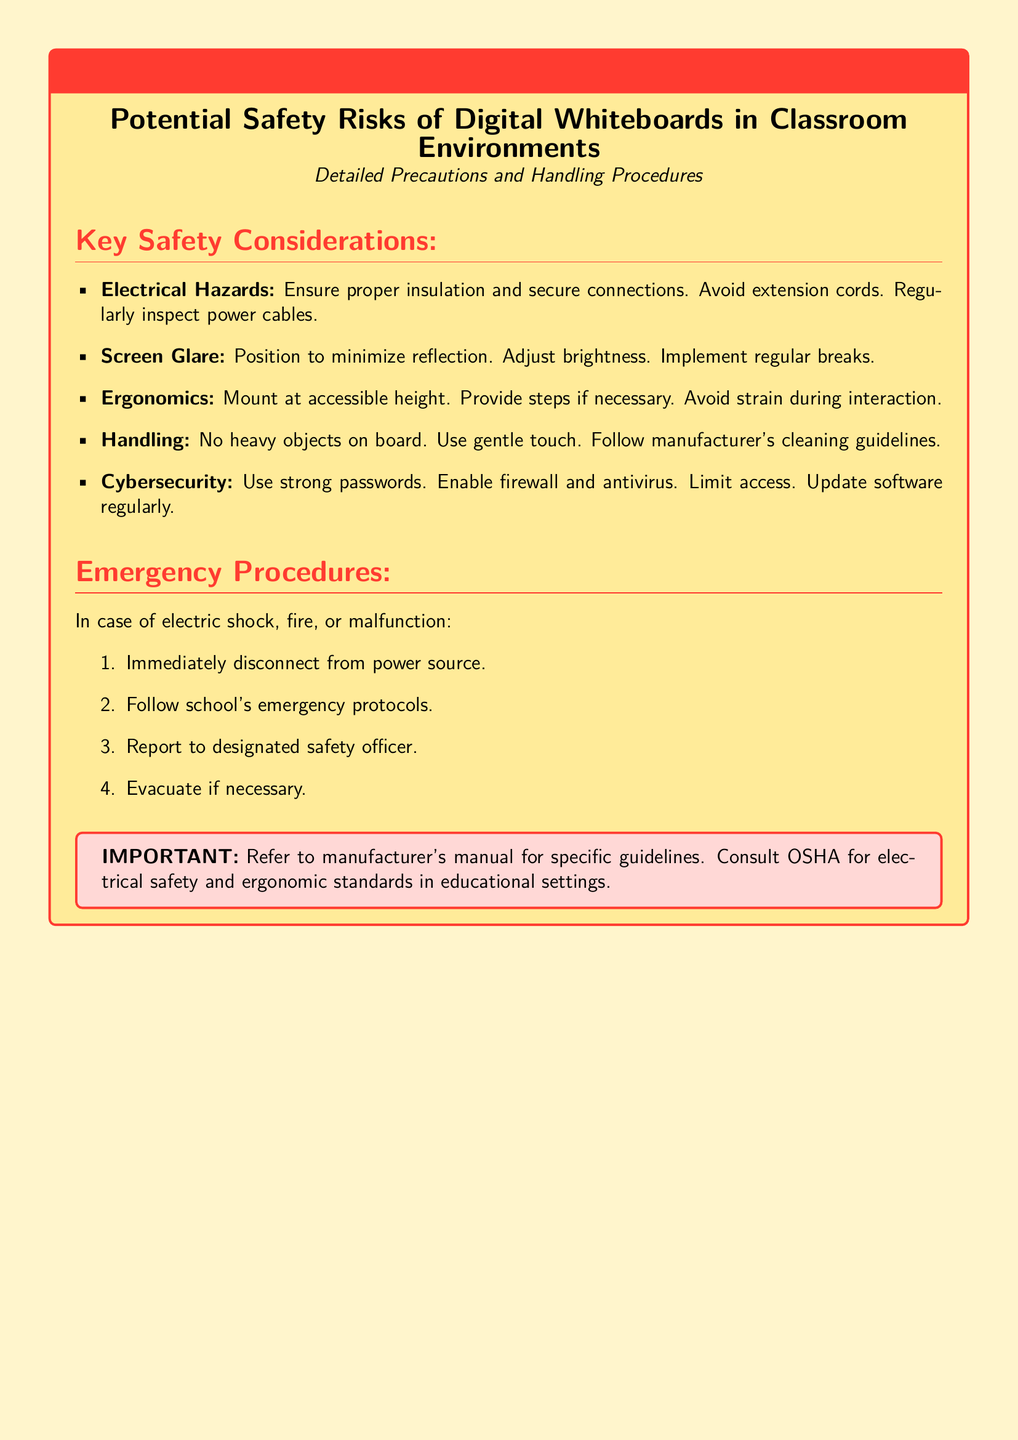What are the electrical hazards mentioned? The document lists electrical hazards as ensuring proper insulation, secure connections, avoiding extension cords, and regularly inspecting power cables.
Answer: Electrical Hazards What should be done to handle screen glare? The document suggests positioning to minimize reflection, adjusting brightness, and implementing regular breaks to handle screen glare.
Answer: Handle screen glare What is the first step in emergency procedures? The emergency procedures specify that the first step in case of electric shock, fire, or malfunction is to immediately disconnect from the power source.
Answer: Disconnect from power source What is the color of the warning box title? The warning box title is specified to be in warning red color as per the document formatting.
Answer: Warning red What guidelines are emphasized for cleaning the digital whiteboard? The document emphasizes following the manufacturer's cleaning guidelines for proper care of the digital whiteboard.
Answer: Manufacturer's cleaning guidelines 